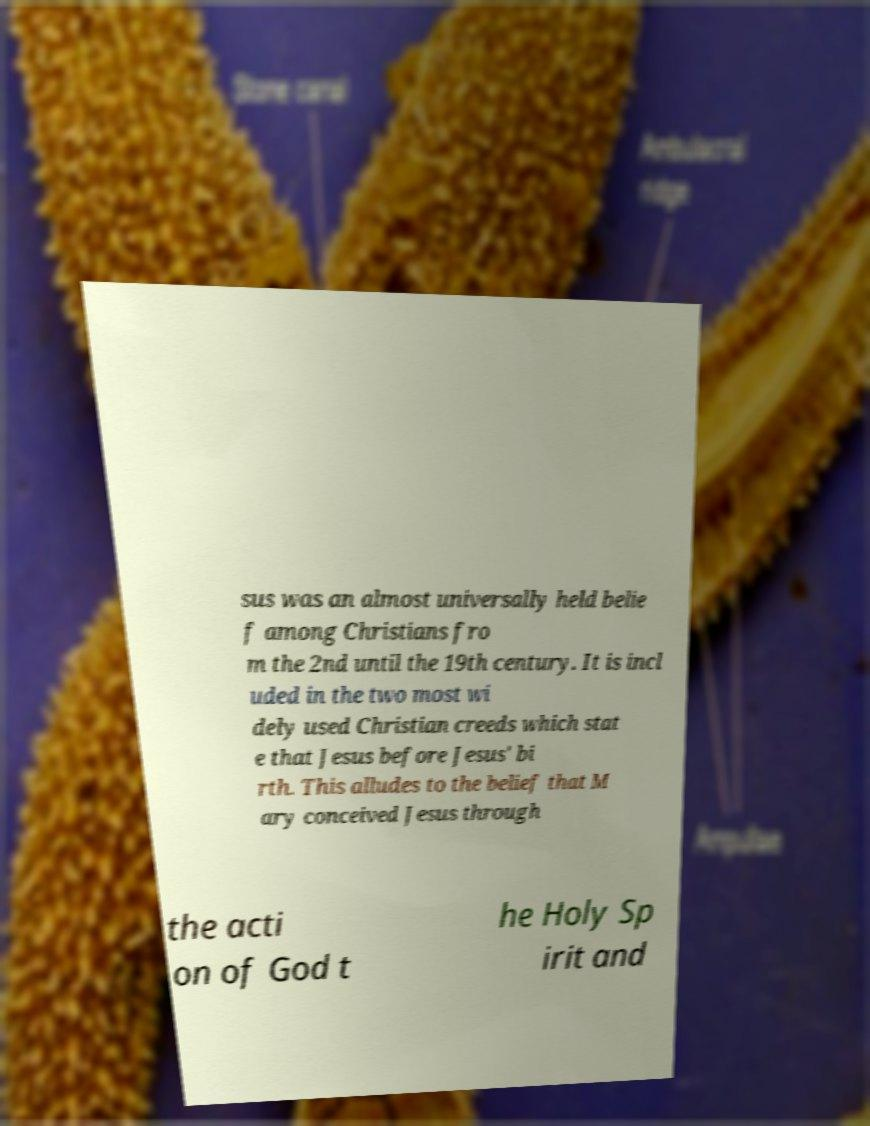There's text embedded in this image that I need extracted. Can you transcribe it verbatim? sus was an almost universally held belie f among Christians fro m the 2nd until the 19th century. It is incl uded in the two most wi dely used Christian creeds which stat e that Jesus before Jesus' bi rth. This alludes to the belief that M ary conceived Jesus through the acti on of God t he Holy Sp irit and 